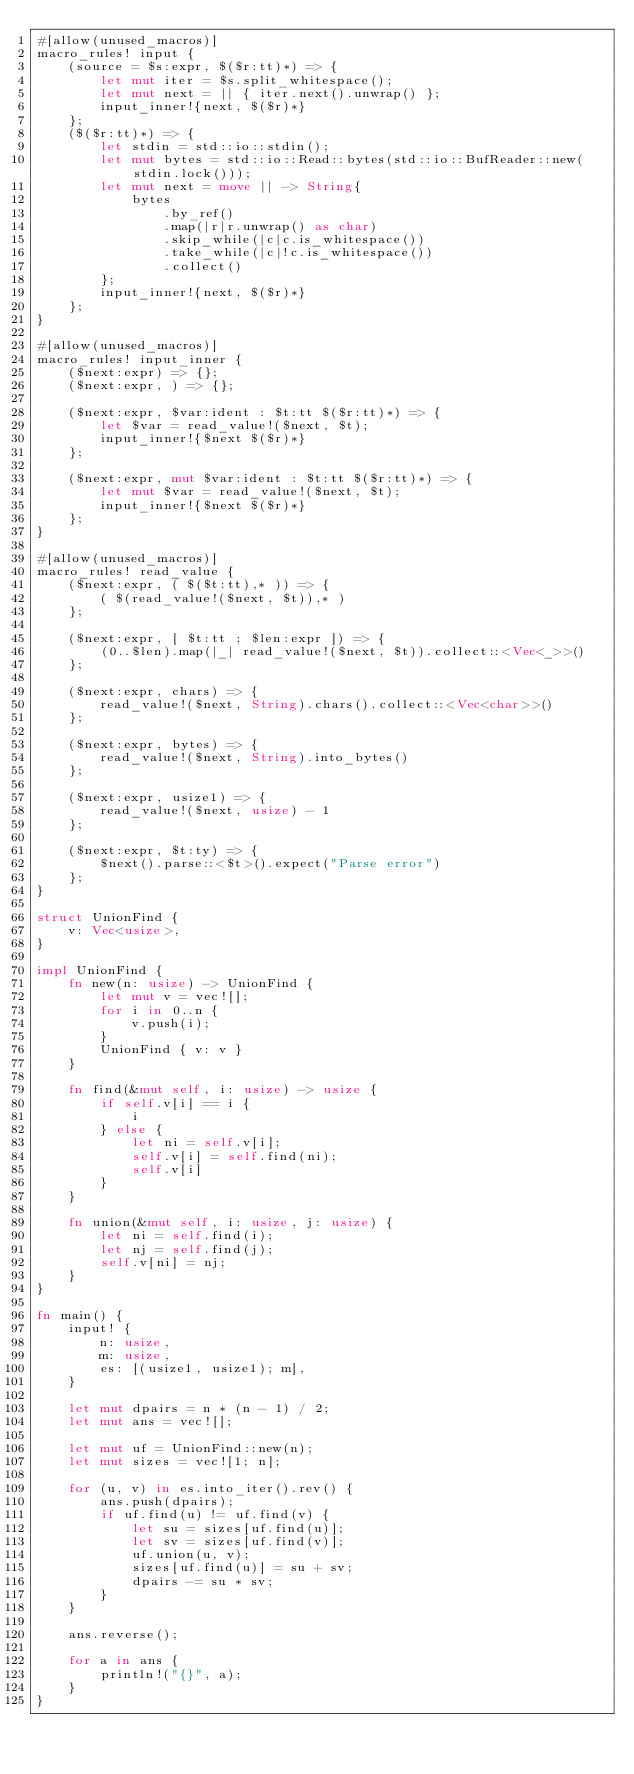<code> <loc_0><loc_0><loc_500><loc_500><_Rust_>#[allow(unused_macros)]
macro_rules! input {
    (source = $s:expr, $($r:tt)*) => {
        let mut iter = $s.split_whitespace();
        let mut next = || { iter.next().unwrap() };
        input_inner!{next, $($r)*}
    };
    ($($r:tt)*) => {
        let stdin = std::io::stdin();
        let mut bytes = std::io::Read::bytes(std::io::BufReader::new(stdin.lock()));
        let mut next = move || -> String{
            bytes
                .by_ref()
                .map(|r|r.unwrap() as char)
                .skip_while(|c|c.is_whitespace())
                .take_while(|c|!c.is_whitespace())
                .collect()
        };
        input_inner!{next, $($r)*}
    };
}

#[allow(unused_macros)]
macro_rules! input_inner {
    ($next:expr) => {};
    ($next:expr, ) => {};

    ($next:expr, $var:ident : $t:tt $($r:tt)*) => {
        let $var = read_value!($next, $t);
        input_inner!{$next $($r)*}
    };

    ($next:expr, mut $var:ident : $t:tt $($r:tt)*) => {
        let mut $var = read_value!($next, $t);
        input_inner!{$next $($r)*}
    };
}

#[allow(unused_macros)]
macro_rules! read_value {
    ($next:expr, ( $($t:tt),* )) => {
        ( $(read_value!($next, $t)),* )
    };

    ($next:expr, [ $t:tt ; $len:expr ]) => {
        (0..$len).map(|_| read_value!($next, $t)).collect::<Vec<_>>()
    };

    ($next:expr, chars) => {
        read_value!($next, String).chars().collect::<Vec<char>>()
    };

    ($next:expr, bytes) => {
        read_value!($next, String).into_bytes()
    };

    ($next:expr, usize1) => {
        read_value!($next, usize) - 1
    };

    ($next:expr, $t:ty) => {
        $next().parse::<$t>().expect("Parse error")
    };
}

struct UnionFind {
    v: Vec<usize>,
}

impl UnionFind {
    fn new(n: usize) -> UnionFind {
        let mut v = vec![];
        for i in 0..n {
            v.push(i);
        }
        UnionFind { v: v }
    }

    fn find(&mut self, i: usize) -> usize {
        if self.v[i] == i {
            i
        } else {
            let ni = self.v[i];
            self.v[i] = self.find(ni);
            self.v[i]
        }
    }

    fn union(&mut self, i: usize, j: usize) {
        let ni = self.find(i);
        let nj = self.find(j);
        self.v[ni] = nj;
    }
}

fn main() {
    input! {
        n: usize,
        m: usize,
        es: [(usize1, usize1); m],
    }

    let mut dpairs = n * (n - 1) / 2;
    let mut ans = vec![];

    let mut uf = UnionFind::new(n);
    let mut sizes = vec![1; n];

    for (u, v) in es.into_iter().rev() {
        ans.push(dpairs);
        if uf.find(u) != uf.find(v) {
            let su = sizes[uf.find(u)];
            let sv = sizes[uf.find(v)];
            uf.union(u, v);
            sizes[uf.find(u)] = su + sv;
            dpairs -= su * sv;
        }
    }

    ans.reverse();

    for a in ans {
        println!("{}", a);
    }
}
</code> 